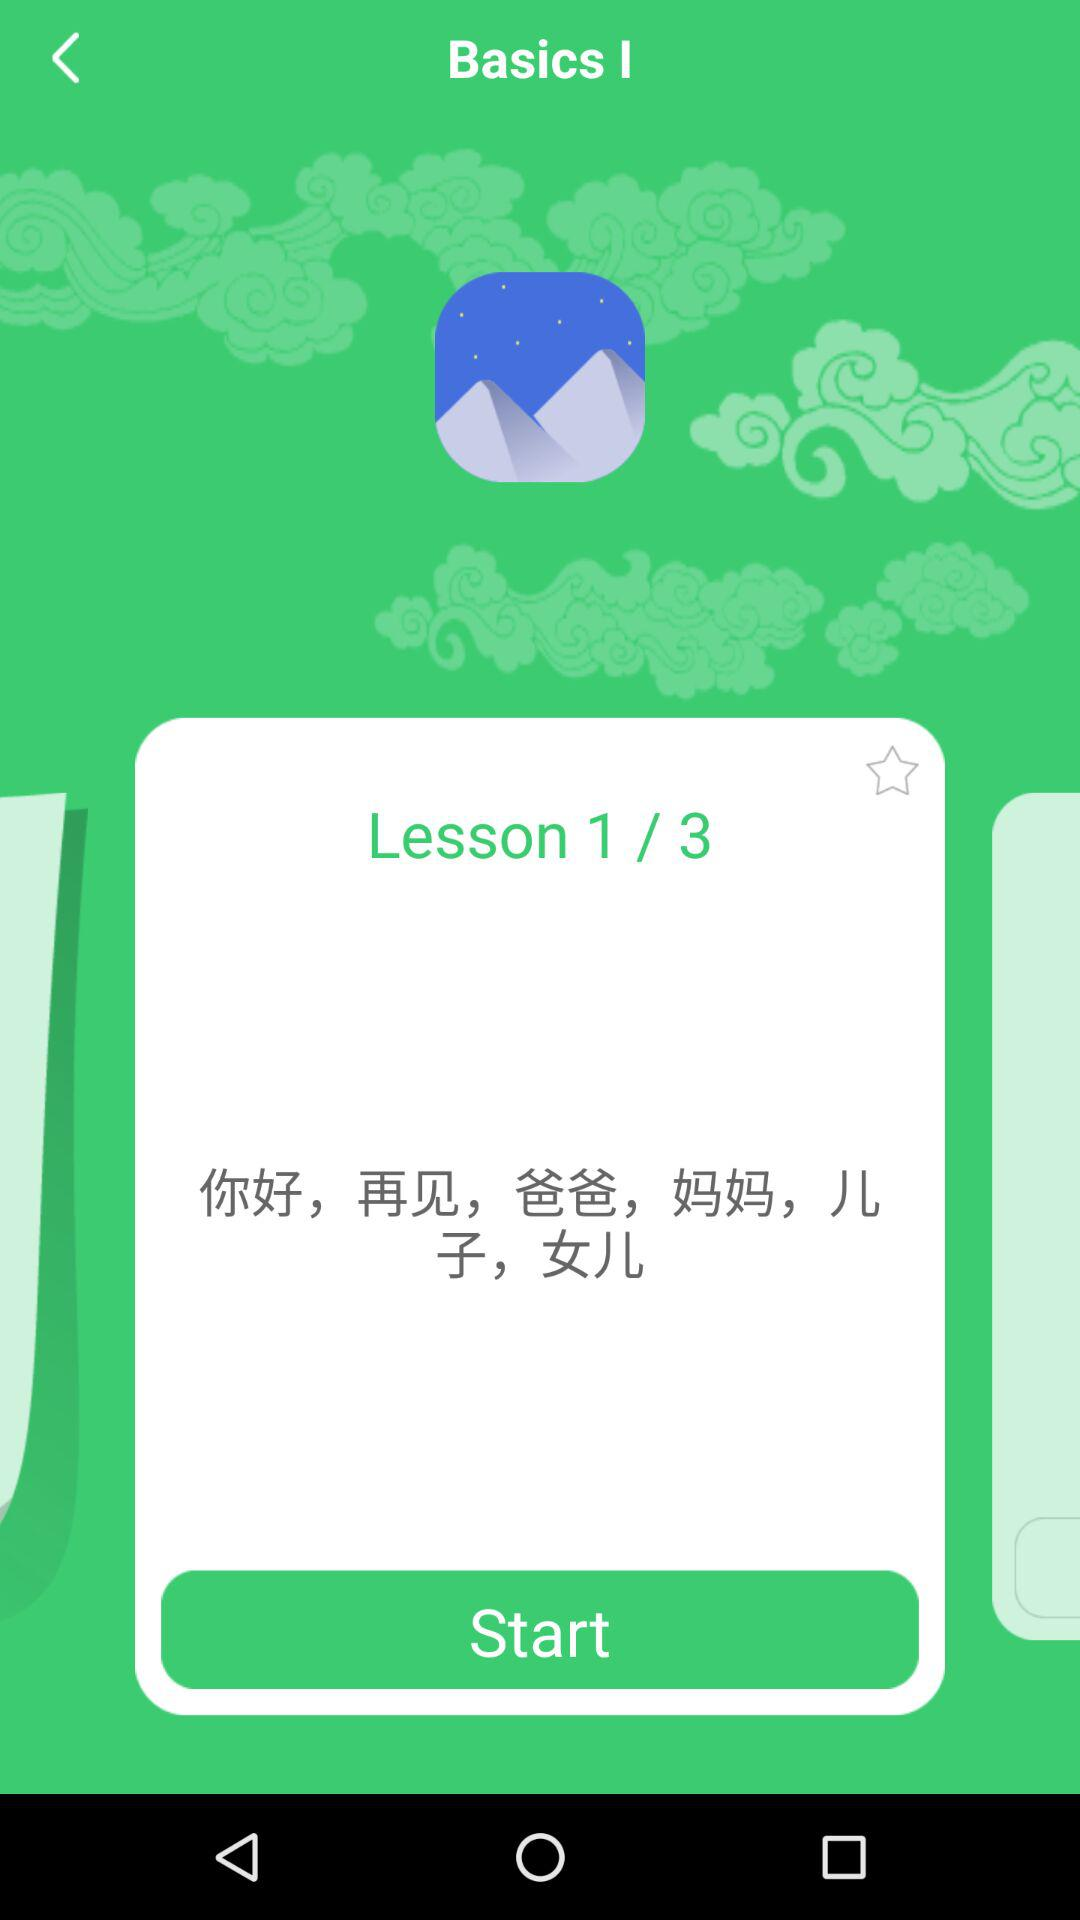How many lessons in total are there? There are a total of 3 lessons. 